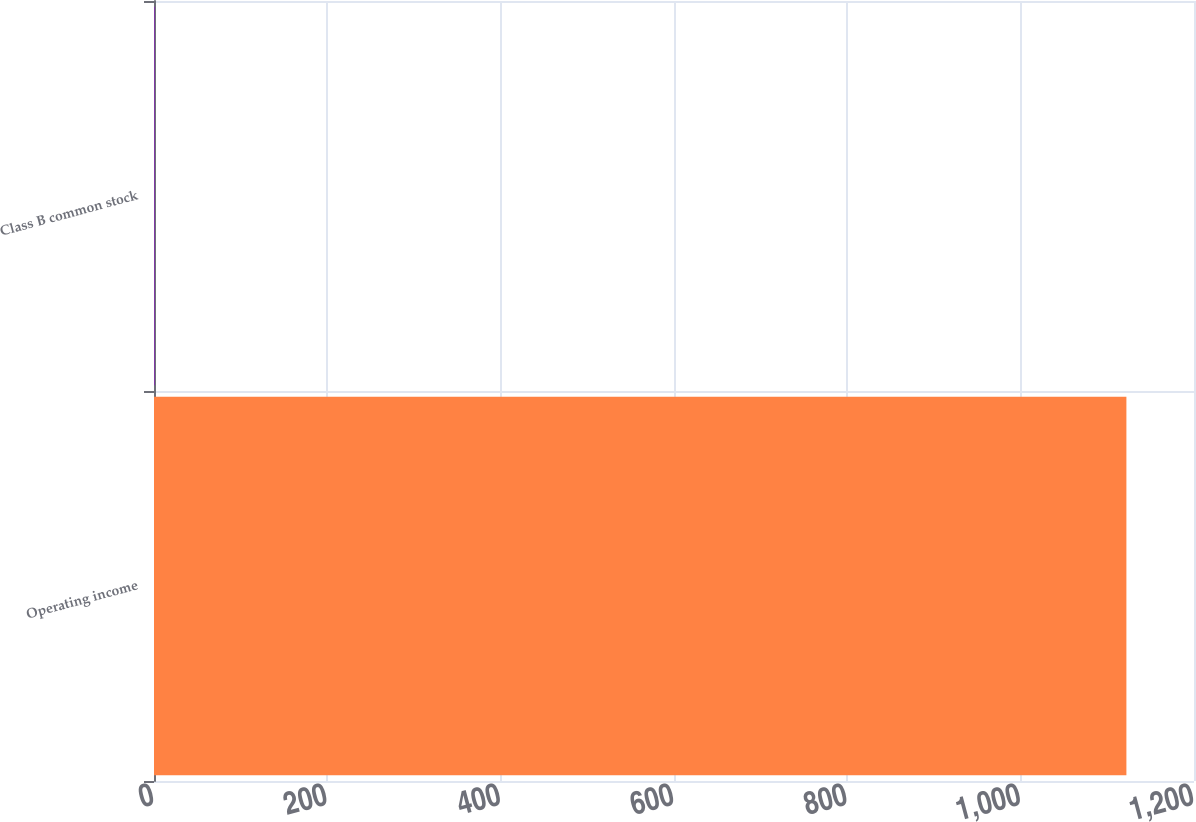<chart> <loc_0><loc_0><loc_500><loc_500><bar_chart><fcel>Operating income<fcel>Class B common stock<nl><fcel>1122<fcel>0.56<nl></chart> 